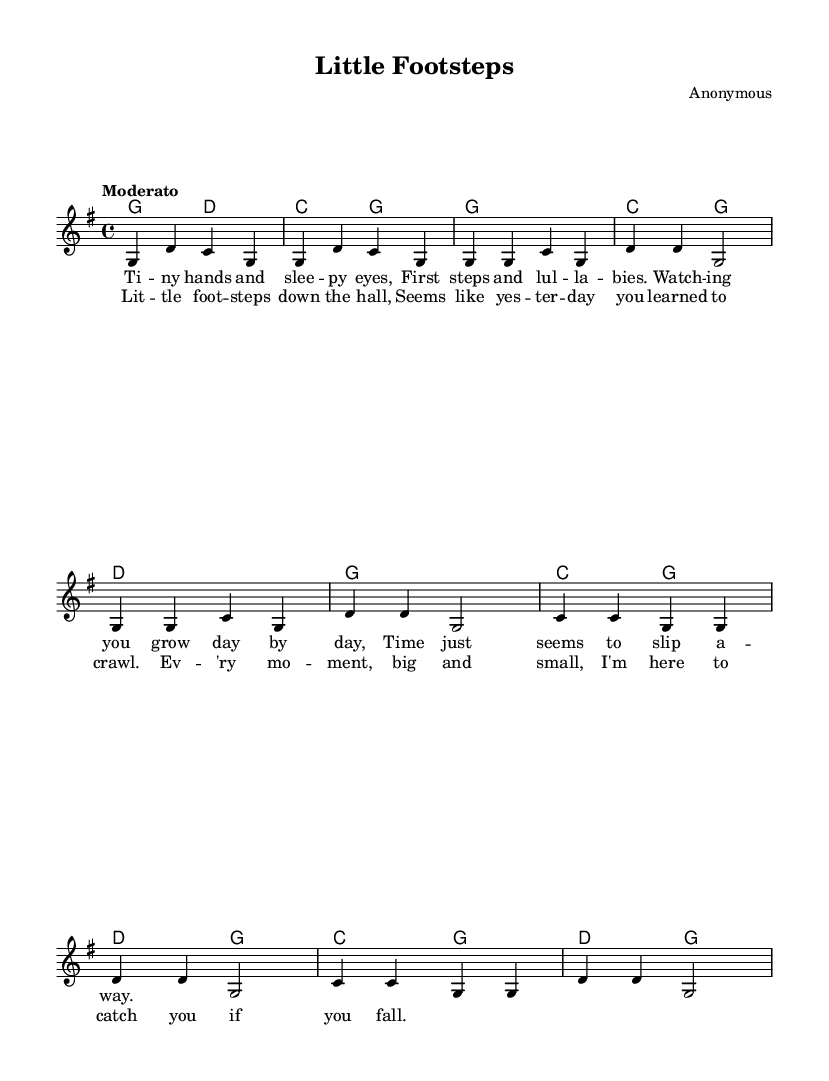What is the key signature of this music? The key signature is G major, which has one sharp (F#).
Answer: G major What is the time signature of this music? The time signature is 4/4, which indicates four beats per measure.
Answer: 4/4 What is the tempo marking for this piece? The tempo marking is "Moderato," which suggests a moderate speed for the performance.
Answer: Moderato How many measures are in the chorus? The chorus consists of four measures as indicated by the four lines of lyrics in that section.
Answer: 4 Which musical elements upholds the theme of childhood in the lyrics? The lyrics mention "tiny hands," "first steps," and "watching you grow," which convey the experiences of watching children develop.
Answer: Tiny hands, first steps, watching you grow What do the repeated notes in the melody indicate about the emotional expression in the song? The repeated notes, particularly in the chorus, emphasize feelings of nostalgia and affection associated with watching a child grow.
Answer: Nostalgia and affection 